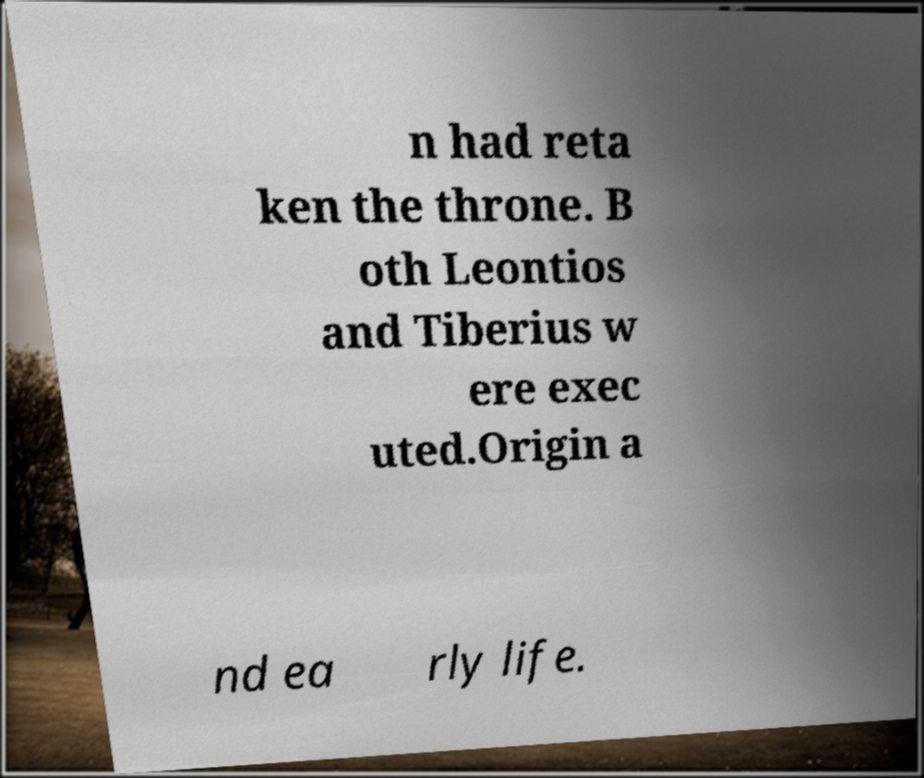Can you accurately transcribe the text from the provided image for me? n had reta ken the throne. B oth Leontios and Tiberius w ere exec uted.Origin a nd ea rly life. 